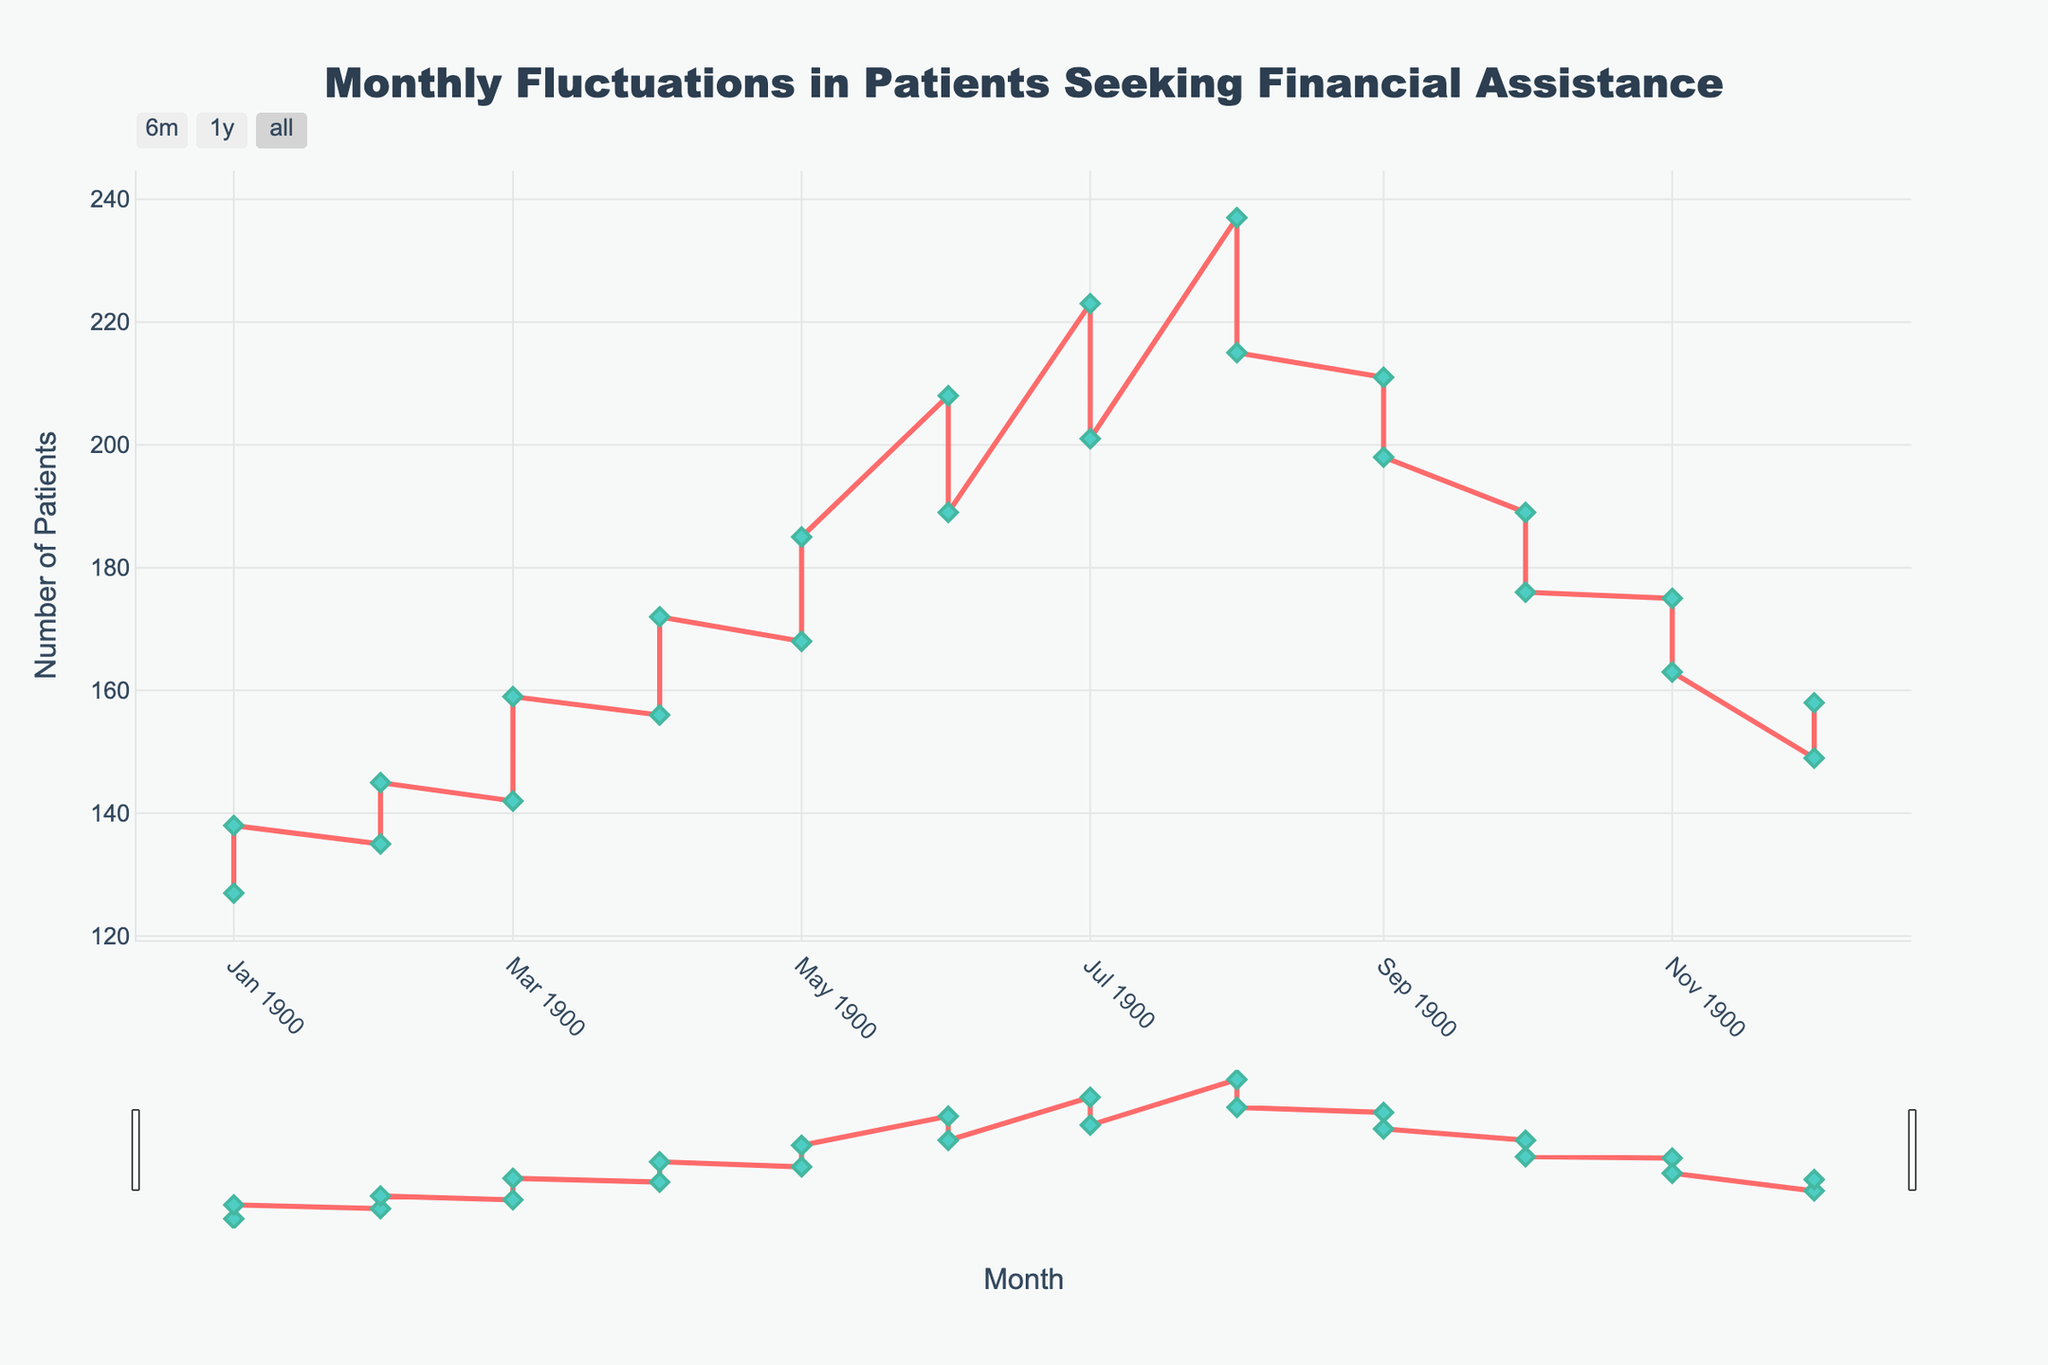What's the highest number of patients seeking financial assistance in a single month? Look at the highest peak in the plotted line on the chart. The highest point corresponds to August with 237 patients.
Answer: 237 What is the general trend in the number of patients seeking financial assistance throughout the year? Observe the overall direction of the line on the chart from start to finish. The line shows an upward trend initially, peaking around mid-year, followed by a decline towards the end of the year.
Answer: Increases initially, peaks mid-year, then decreases In which month did the number of patients seeking financial assistance start to decline after reaching its peak? Identify the highest point on the chart and see what follows. After peaking in August at 237 patients, there is a noticeable decline in September.
Answer: September Compare the number of patients seeking financial assistance in February and December of the second year. Which month had more patients? Locate the data points for February and December in the second year and compare their values. February had 145, while December had 158, so December had more.
Answer: December What is the average number of patients seeking financial assistance from July to December of the first year? Identify the values from July to December: 201, 215, 198, 176, 163, 149. Calculate the average: (201 + 215 + 198 + 176 + 163 + 149) / 6 = 1102 / 6 ≈ 183.67.
Answer: 183.67 How many patients sought financial assistance in both August months combined? Locate the data points for August in both years: 215 and 237. Sum them up: 215 + 237 = 452.
Answer: 452 What is the difference in the number of patients seeking financial assistance between April of the first year and April of the second year? Locate the April data points for both years: 156 in the first year and 172 in the second. Calculate the difference: 172 - 156 = 16.
Answer: 16 